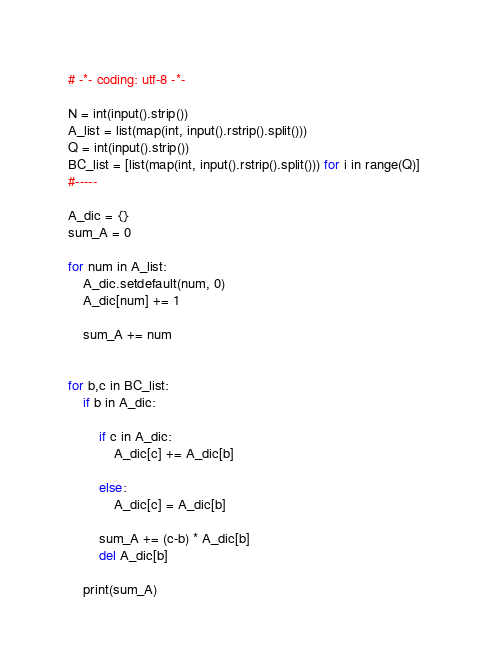<code> <loc_0><loc_0><loc_500><loc_500><_Python_># -*- coding: utf-8 -*-

N = int(input().strip())
A_list = list(map(int, input().rstrip().split()))
Q = int(input().strip())
BC_list = [list(map(int, input().rstrip().split())) for i in range(Q)]
#-----

A_dic = {}
sum_A = 0

for num in A_list:
    A_dic.setdefault(num, 0)
    A_dic[num] += 1

    sum_A += num


for b,c in BC_list:
    if b in A_dic:
    
        if c in A_dic:
            A_dic[c] += A_dic[b]
            
        else:
            A_dic[c] = A_dic[b]
    
        sum_A += (c-b) * A_dic[b]
        del A_dic[b]
    
    print(sum_A)
</code> 